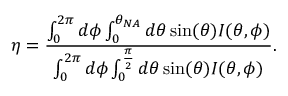<formula> <loc_0><loc_0><loc_500><loc_500>\eta = \frac { \int _ { 0 } ^ { 2 \pi } d \phi \int _ { 0 } ^ { \theta _ { N A } } d \theta \sin ( \theta ) I ( \theta , \phi ) } { \int _ { 0 } ^ { 2 \pi } d \phi \int _ { 0 } ^ { \frac { \pi } { 2 } } d \theta \sin ( \theta ) I ( \theta , \phi ) } .</formula> 